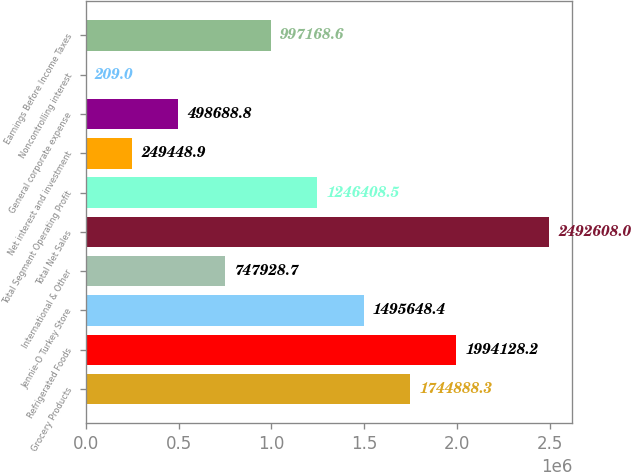Convert chart to OTSL. <chart><loc_0><loc_0><loc_500><loc_500><bar_chart><fcel>Grocery Products<fcel>Refrigerated Foods<fcel>Jennie-O Turkey Store<fcel>International & Other<fcel>Total Net Sales<fcel>Total Segment Operating Profit<fcel>Net interest and investment<fcel>General corporate expense<fcel>Noncontrolling interest<fcel>Earnings Before Income Taxes<nl><fcel>1.74489e+06<fcel>1.99413e+06<fcel>1.49565e+06<fcel>747929<fcel>2.49261e+06<fcel>1.24641e+06<fcel>249449<fcel>498689<fcel>209<fcel>997169<nl></chart> 